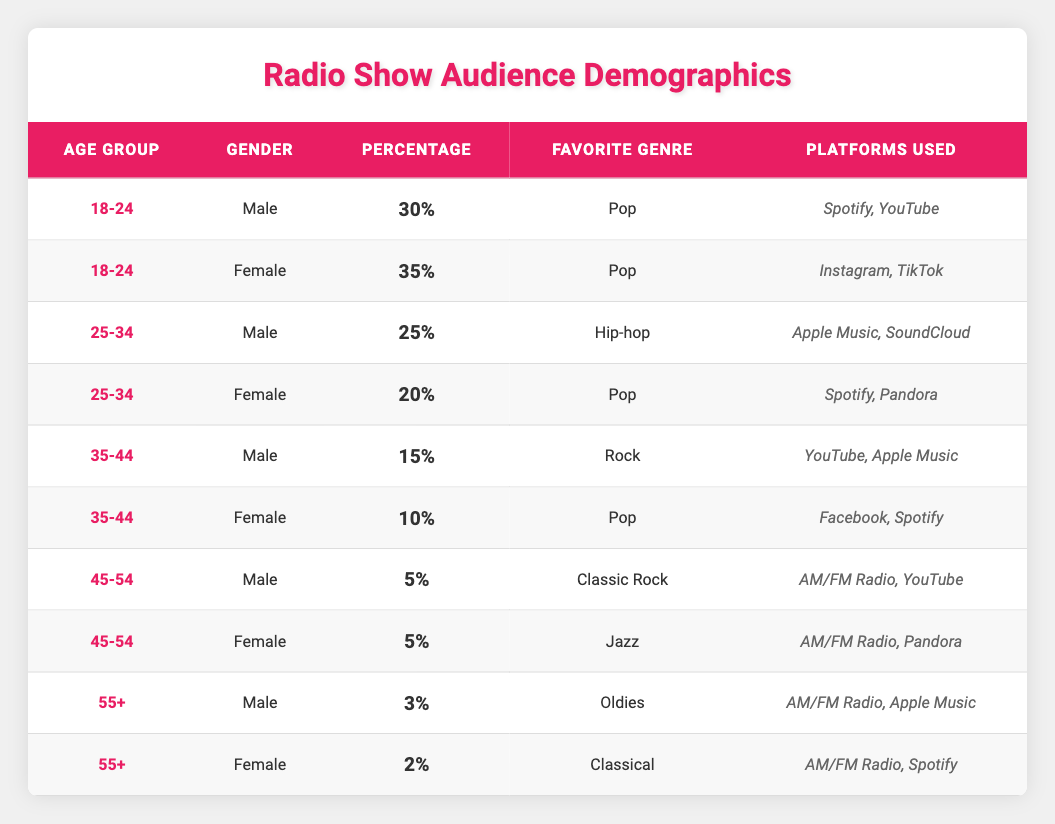What percentage of the radio show's audience is male in the 18-24 age group? In the table, there is one entry for "18-24" age group and "Male" gender, which shows a percentage of 30%. Therefore, the percentage of male listeners aged 18-24 is 30%.
Answer: 30% What is the favorite genre of female listeners aged 35-44? Looking at the age group "35-44" and the gender "Female" in the table, we see that their favorite genre is "Pop."
Answer: Pop Is the percentage of males in the 25-34 age group higher than that in the 35-44 age group? The percentage of males in the 25-34 age group is 25%, while in the 35-44 age group, it is 15%. Since 25% is greater than 15%, the answer is yes.
Answer: Yes What is the total percentage of female listeners across all age groups? We can sum the percentages of female listeners from each age group: 35% (18-24) + 20% (25-34) + 10% (35-44) + 5% (45-54) + 2% (55+) = 72%. Therefore, the total percentage of female listeners is 72%.
Answer: 72% In the age group of 55 and above, which gender has a higher percentage? The table shows that males have a percentage of 3% while females have a percentage of 2% in the age group of 55+. Since 3% is greater than 2%, the answer is male.
Answer: Male What is the difference in percentage between male listeners aged 18-24 and those aged 25-34? The percentage for males in the 18-24 age group is 30% and in the 25-34 age group is 25%. The difference can be calculated as 30% - 25% = 5%.
Answer: 5% Do more listeners prefer Pop as their favorite genre compared to those who prefer Rock? The table indicates that the percentage of listeners who prefer Pop (female 35% in 18-24, female 20% in 25-34, and female 10% in 35-44) is 65% combined. For Rock, the percentage is only 15% (male 15% in 35-44). Since 65% > 15%, the answer is yes.
Answer: Yes What platforms do female listeners aged 25-34 primarily use? According to the table for females aged 25-34, the platforms used are "Spotify" and "Pandora." Therefore, these are the primary platforms for this group.
Answer: Spotify, Pandora 